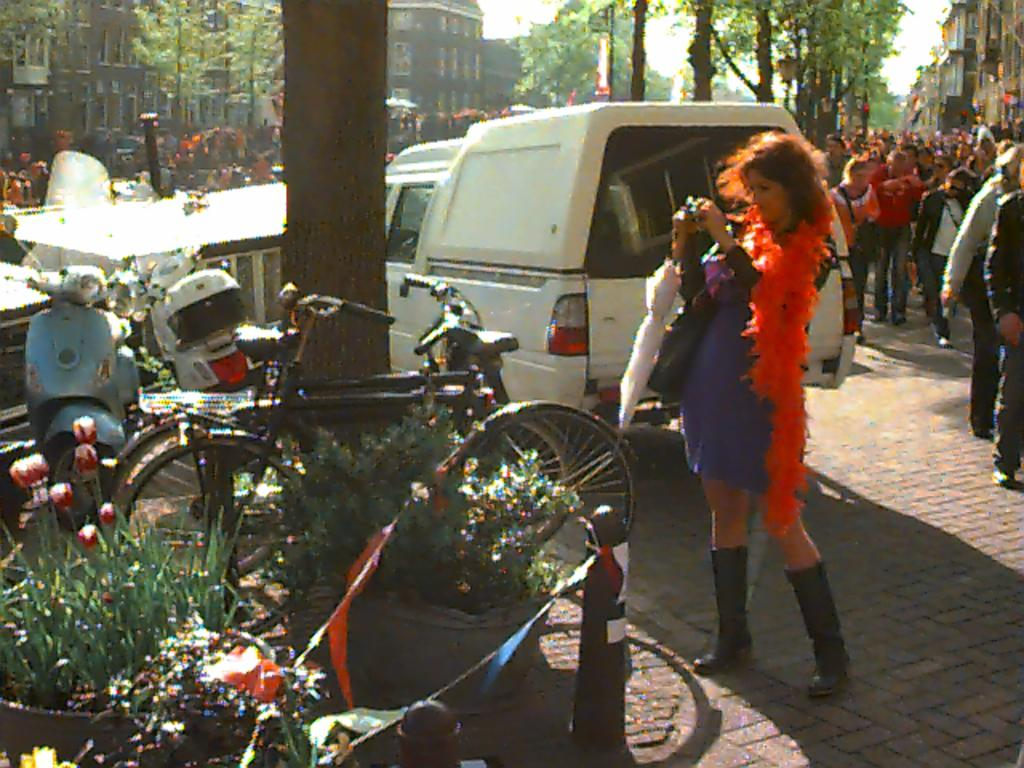Who or what is present in the image? There are people in the image. What can be seen on the left side of the image? There are vehicles on the left side of the image. What is visible in the background of the image? There are trees and buildings in the background of the image. What type of rod can be seen near the seashore in the image? There is no rod or seashore present in the image. 